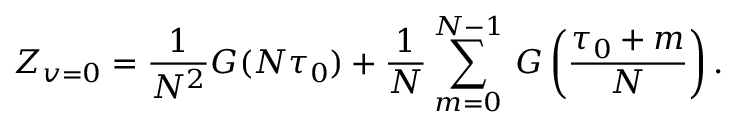Convert formula to latex. <formula><loc_0><loc_0><loc_500><loc_500>Z _ { v = 0 } = \frac { 1 } { N ^ { 2 } } G ( N \tau _ { 0 } ) + \frac { 1 } { N } \sum _ { m = 0 } ^ { N - 1 } \, G \left ( \frac { \tau _ { 0 } + m } { N } \right ) .</formula> 